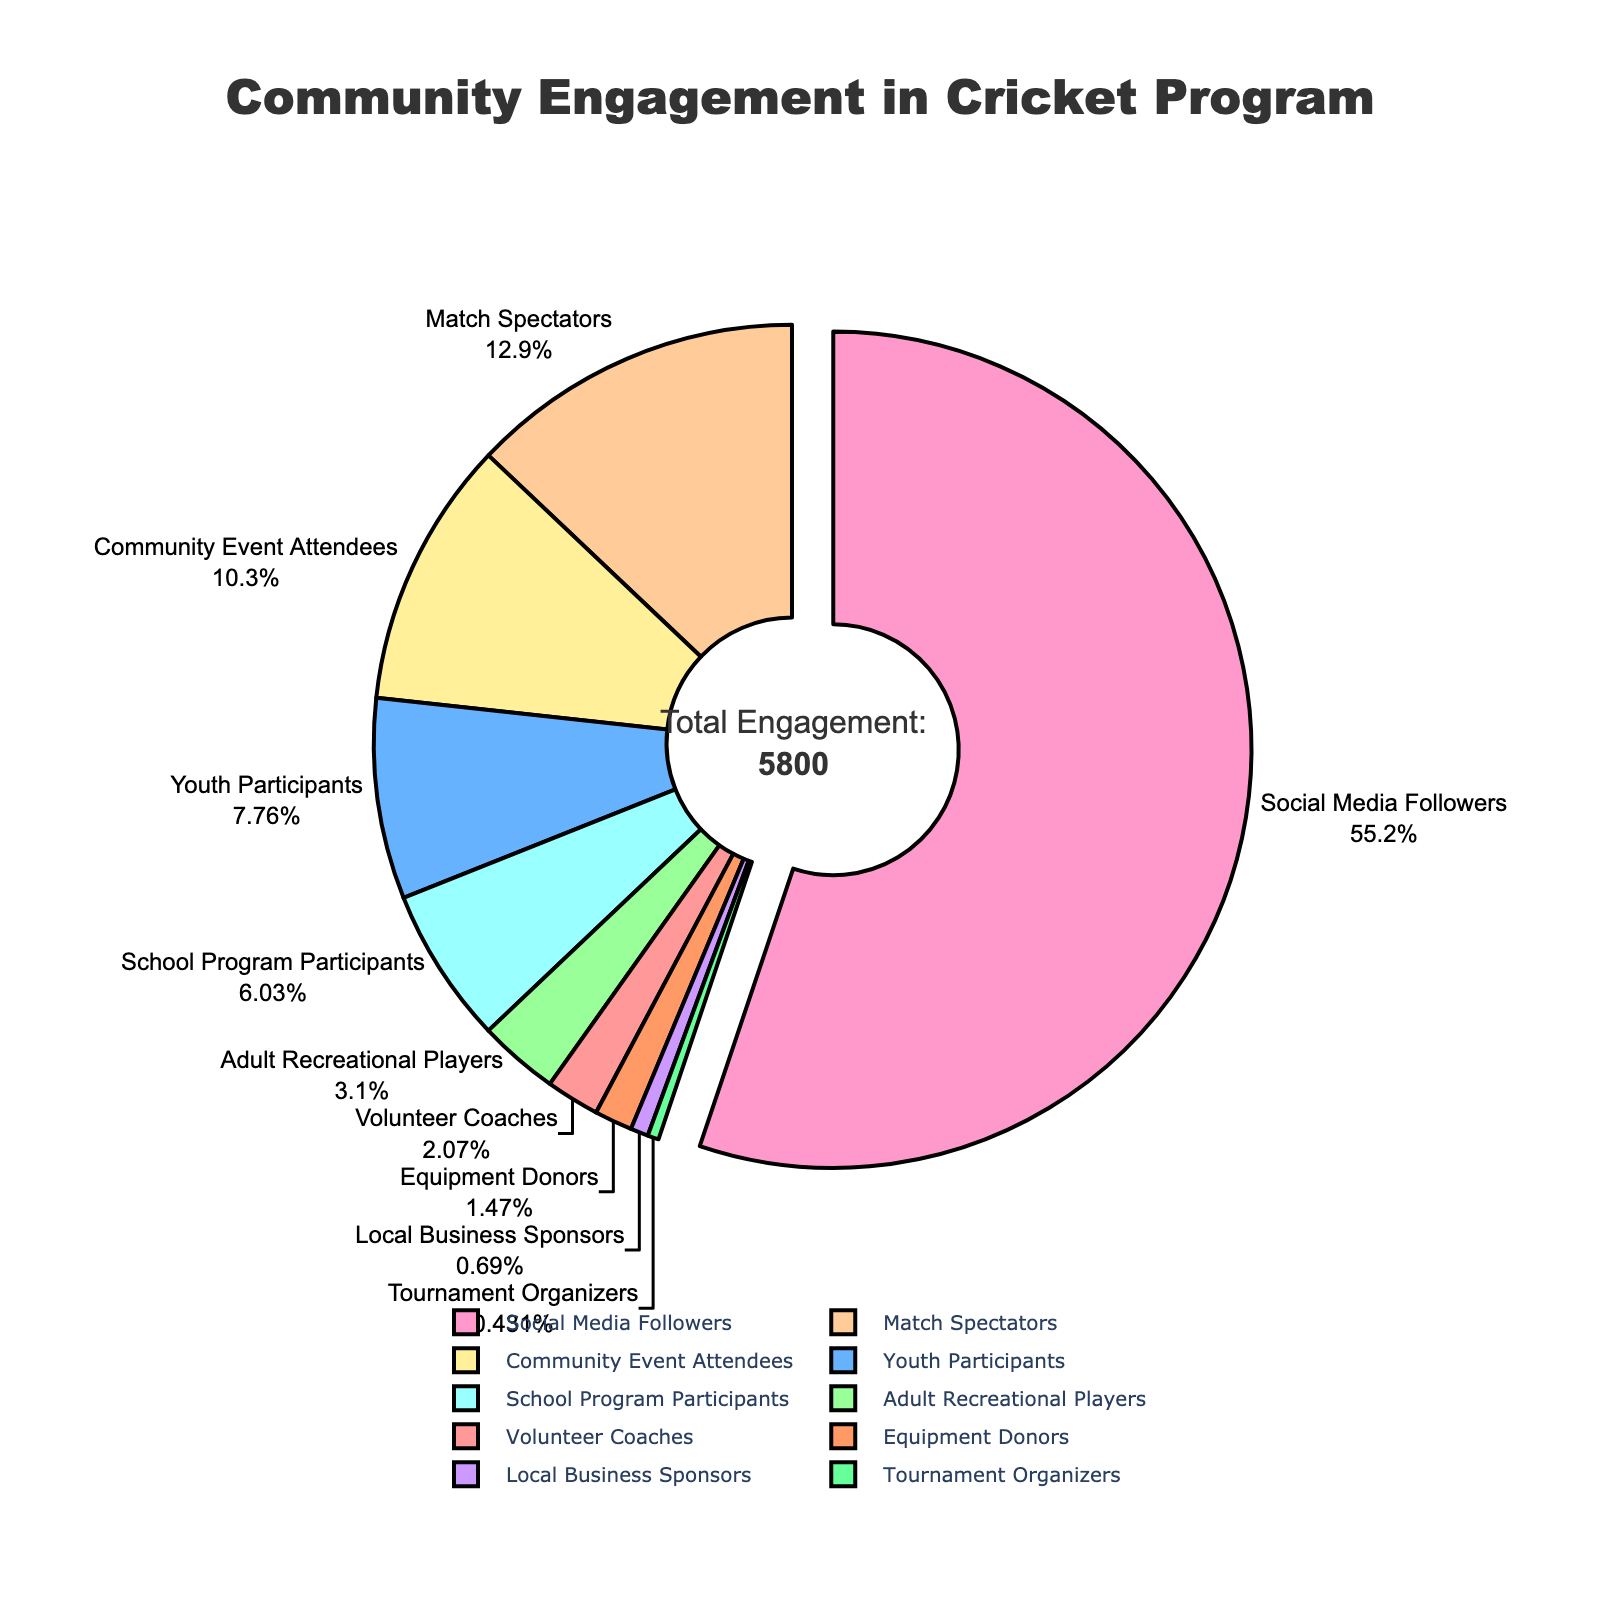What is the total value represented in the pie chart? The title annotation indicates the total engagement is calculated by summing all values. So, the total is 120 (Volunteer Coaches) + 450 (Youth Participants) + 180 (Adult Recreational Players) + 750 (Match Spectators) + 3200 (Social Media Followers) + 600 (Community Event Attendees) + 350 (School Program Participants) + 40 (Local Business Sponsors) + 85 (Equipment Donors) + 25 (Tournament Organizers) = 5800.
Answer: 5800 Which category has the highest engagement? By looking at the pie chart, the largest pulled-out segment represents the category with the highest number. The segment for "Social Media Followers" is the largest and is pulled out.
Answer: Social Media Followers How many participants are involved in school and youth programs combined? Sum the values of "School Program Participants" and "Youth Participants": 350 (School Program Participants) + 450 (Youth Participants) = 800.
Answer: 800 What percentage of the total engagement is represented by match spectators? The pie chart shows match spectators as a segment of the total. The percentage can be calculated as (750 / 5800) * 100.
Answer: 12.93% Which category has least representation and what is its value? The smallest segment in the pie chart represents the least engagement. It is "Tournament Organizers" with a value of 25.
Answer: Tournament Organizers, 25 How does the number of adult recreational players compare to the number of youth participants? Compare the segments of "Adult Recreational Players" and "Youth Participants". "Youth Participants" has 450, which is more compared to "Adult Recreational Players" with 180.
Answer: Youth Participants > Adult Recreational Players What is the combined value of local business sponsors and equipment donors? Sum the values of "Local Business Sponsors" and "Equipment Donors": 40 (Local Business Sponsors) + 85 (Equipment Donors) = 125.
Answer: 125 Which segment is represented in blue color and what is its value? The "blue" segment represents "Youth Participants", and its value is 450.
Answer: Youth Participants, 450 